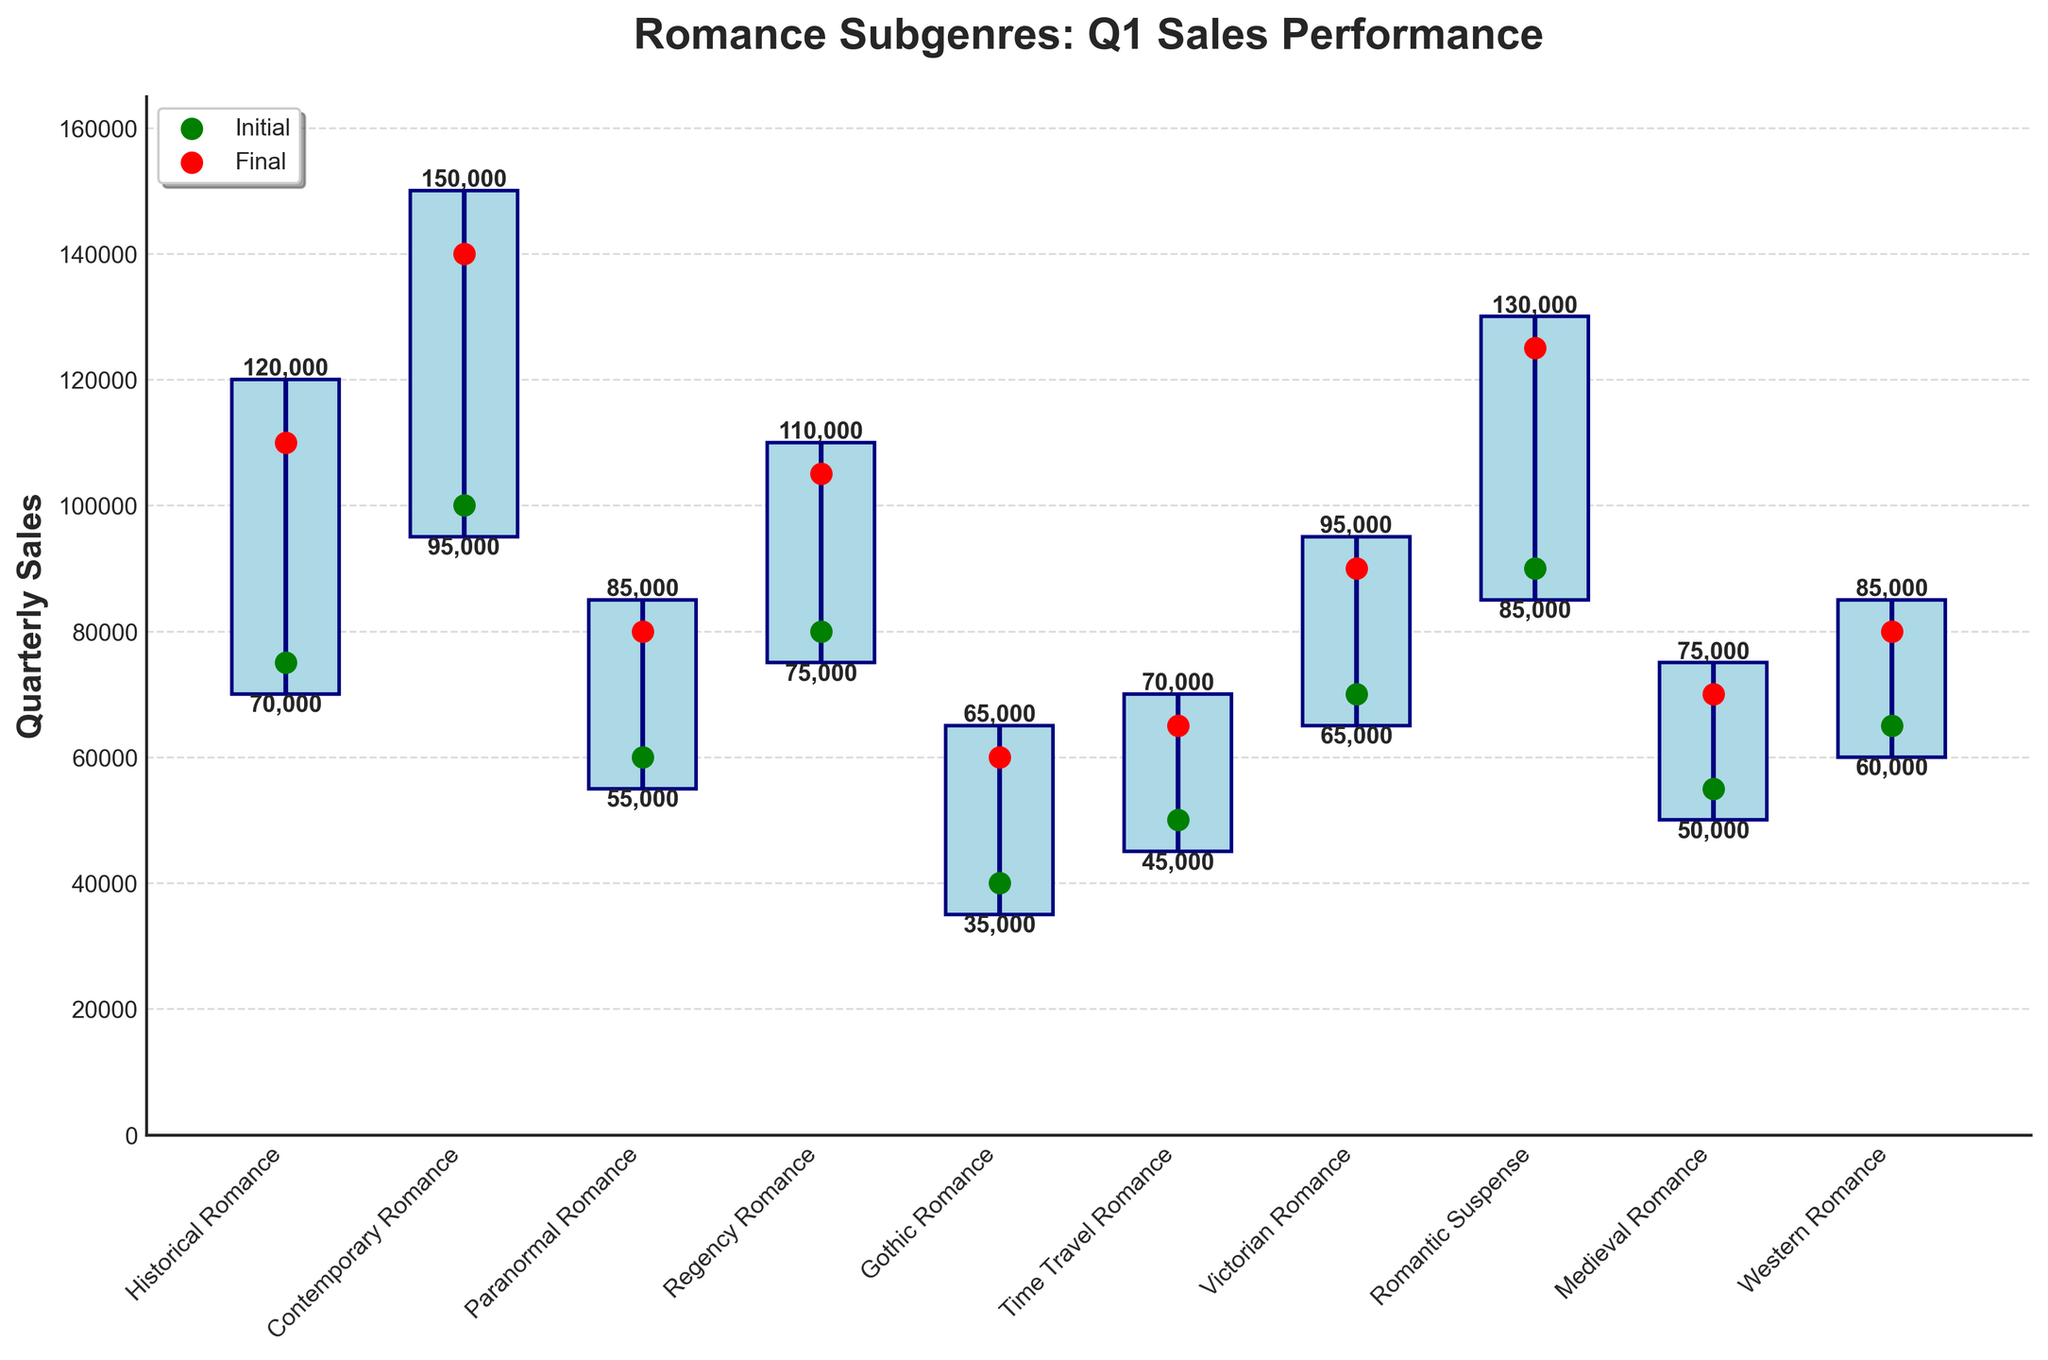What is the title of the figure? The title of the figure is displayed at the top in a larger and bold font. It is meant to provide an overall description of the chart's contents.
Answer: Romance Subgenres: Q1 Sales Performance Which subgenre has the highest initial sales numbers? Looking at the green dots representing the initial sales numbers, identify the highest green dot and refer to its corresponding subgenre on the x-axis.
Answer: Contemporary Romance What is the range of Q1 sales for Historical Romance? The range is the difference between the highest and lowest sales values. For Historical Romance, the highest sales is 120,000 and the lowest is 70,000. Subtract the lowest from the highest: 120,000 - 70,000.
Answer: 50,000 Which two subgenres have the closest final sales numbers? Examine the final sales marked by red dots and look for two red dots that are closest in value. From the x-axis labels, Medieval Romance (70,000) and Western Romance (80,000) have the closest values.
Answer: Paranormal Romance (80,000) and Western Romance (80,000) What are the initial and final sales numbers for Romantic Suspense? Find the green dot for the initial sales and the red dot for the final sales of Romantic Suspense on the chart, then read their values. Initial is 90,000 and final is 125,000.
Answer: 90,000 (Initial), 125,000 (Final) Which subgenre experienced the largest drop in sales during Q1? Identify the subgenre with the largest difference between its highest (light blue bar top) and lowest (light blue bar bottom) sales numbers.
Answer: Gothic Romance Compare the highest sales of Contemporary Romance with Victorian Romance. Locate the highest sales points (top of the bars) for both subgenres and compare their values. Contemporary Romance's highest sales is 150,000, and Victorian Romance's highest sales is 95,000.
Answer: Contemporary Romance has higher sales (150,000 vs. 95,000) How many subgenres have a final sales number greater than 100,000? Count the number of red dots situated above the 100,000 mark on the y-axis. Identify their corresponding subgenres if necessary.
Answer: 5 subgenres Which subgenre has the smallest range of sales in Q1? Determine which subgenre has the smallest difference between its highest and lowest sales values. For each subgenre, calculate the difference and compare across all.
Answer: Medieval Romance What is the combined final sales of Historical Romance, Regency Romance, and Victorian Romance? Add up the final sales values (red dots) for these three subgenres. Historical Romance (110,000), Regency Romance (105,000), and Victorian Romance (90,000): 110,000 + 105,000 + 90,000.
Answer: 305,000 